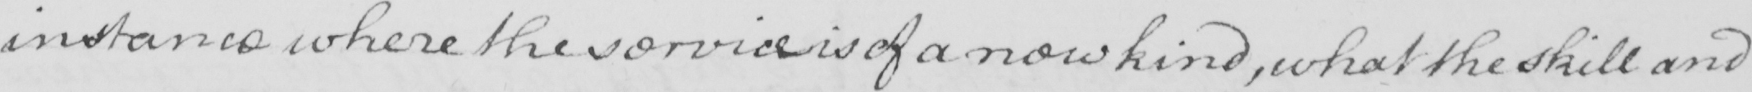Transcribe the text shown in this historical manuscript line. instance where the service is of a new kind , what the skill and 